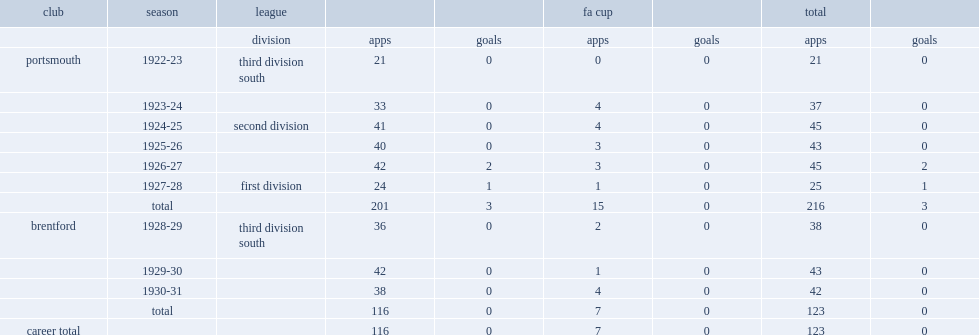How many appearances did reginald davies make in portsmouth? 216.0. How many goals did reginald davies score in portsmouth? 3.0. 